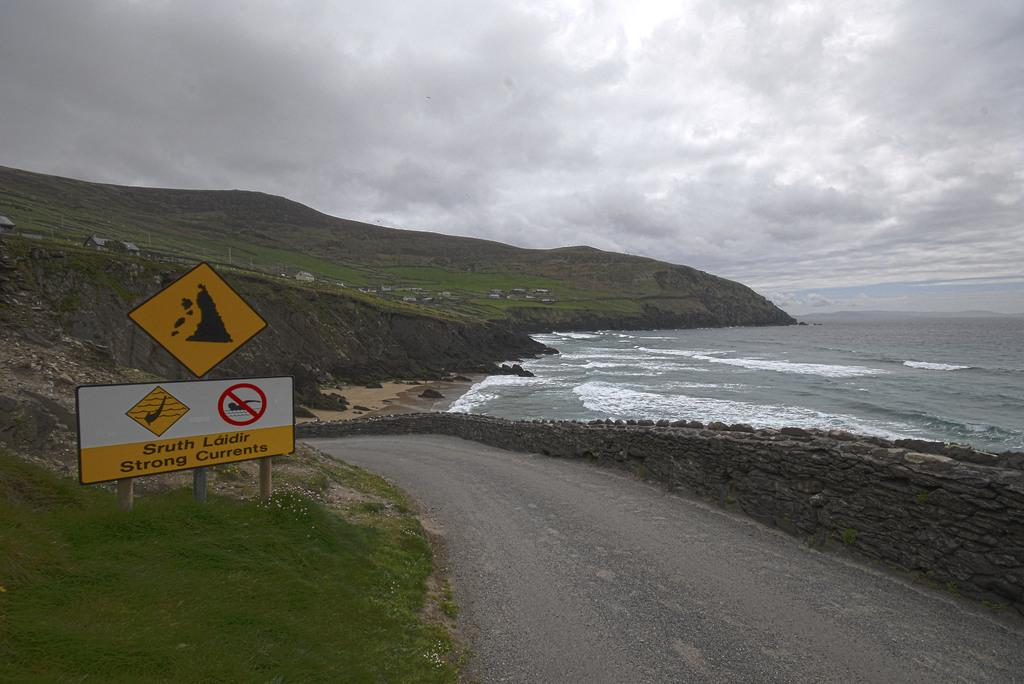<image>
Give a short and clear explanation of the subsequent image. A warning sign on a beach advises of strong currents. 